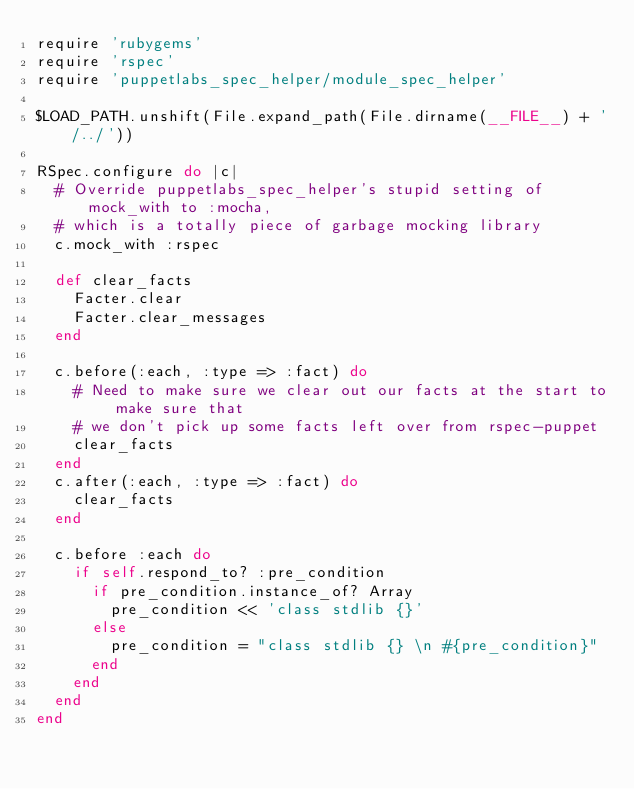Convert code to text. <code><loc_0><loc_0><loc_500><loc_500><_Ruby_>require 'rubygems'
require 'rspec'
require 'puppetlabs_spec_helper/module_spec_helper'

$LOAD_PATH.unshift(File.expand_path(File.dirname(__FILE__) + '/../'))

RSpec.configure do |c|
  # Override puppetlabs_spec_helper's stupid setting of mock_with to :mocha,
  # which is a totally piece of garbage mocking library
  c.mock_with :rspec

  def clear_facts
    Facter.clear
    Facter.clear_messages
  end

  c.before(:each, :type => :fact) do
    # Need to make sure we clear out our facts at the start to make sure that
    # we don't pick up some facts left over from rspec-puppet
    clear_facts
  end
  c.after(:each, :type => :fact) do
    clear_facts
  end

  c.before :each do
    if self.respond_to? :pre_condition
      if pre_condition.instance_of? Array
        pre_condition << 'class stdlib {}'
      else
        pre_condition = "class stdlib {} \n #{pre_condition}"
      end
    end
  end
end
</code> 